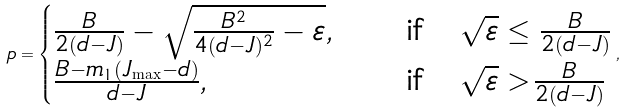<formula> <loc_0><loc_0><loc_500><loc_500>p = \begin{cases} \frac { B } { 2 ( d - J ) } - \sqrt { \frac { B ^ { 2 } } { 4 ( d - J ) ^ { 2 } } - \varepsilon } , \quad & \text {if} \quad \sqrt { \varepsilon } \leq \frac { B } { 2 ( d - J ) } \\ \frac { B - m _ { 1 } ( J _ { \max } - d ) } { d - J } , \quad & \text {if} \quad \sqrt { \varepsilon } > \frac { B } { 2 ( d - J ) } \end{cases} ,</formula> 